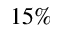<formula> <loc_0><loc_0><loc_500><loc_500>1 5 \%</formula> 